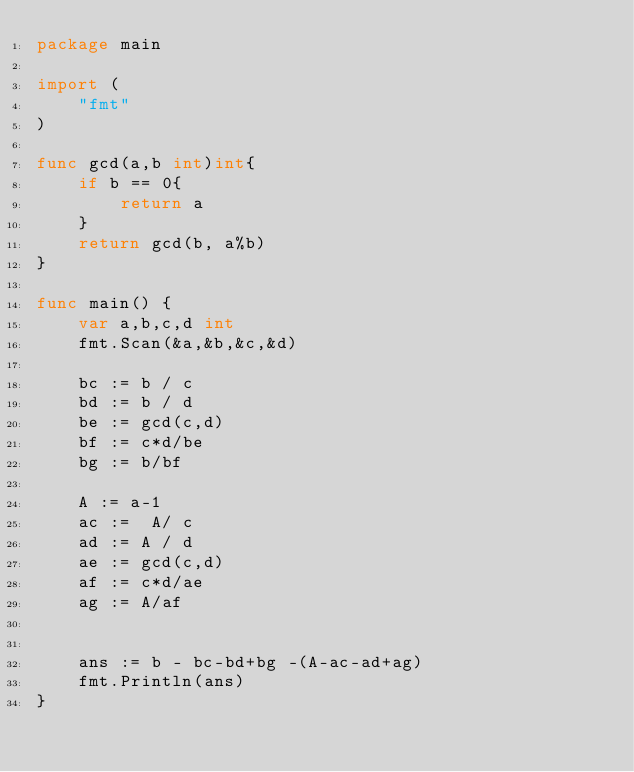Convert code to text. <code><loc_0><loc_0><loc_500><loc_500><_Go_>package main

import (
	"fmt"
)

func gcd(a,b int)int{
	if b == 0{
		return a
	}
	return gcd(b, a%b)
}

func main() {
	var a,b,c,d int
	fmt.Scan(&a,&b,&c,&d)

	bc := b / c
	bd := b / d
	be := gcd(c,d)
	bf := c*d/be
	bg := b/bf
	
	A := a-1
	ac :=  A/ c
	ad := A / d
	ae := gcd(c,d)
	af := c*d/ae
	ag := A/af
	

	ans := b - bc-bd+bg -(A-ac-ad+ag)
	fmt.Println(ans)
}</code> 